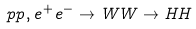Convert formula to latex. <formula><loc_0><loc_0><loc_500><loc_500>p p , e ^ { + } e ^ { - } \to W W \to H H</formula> 